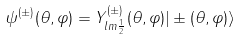<formula> <loc_0><loc_0><loc_500><loc_500>\psi ^ { ( \pm ) } ( \theta , \varphi ) = Y ^ { ( \pm ) } _ { l m \frac { 1 } { 2 } } ( \theta , \varphi ) | \pm ( \theta , \varphi ) \rangle</formula> 